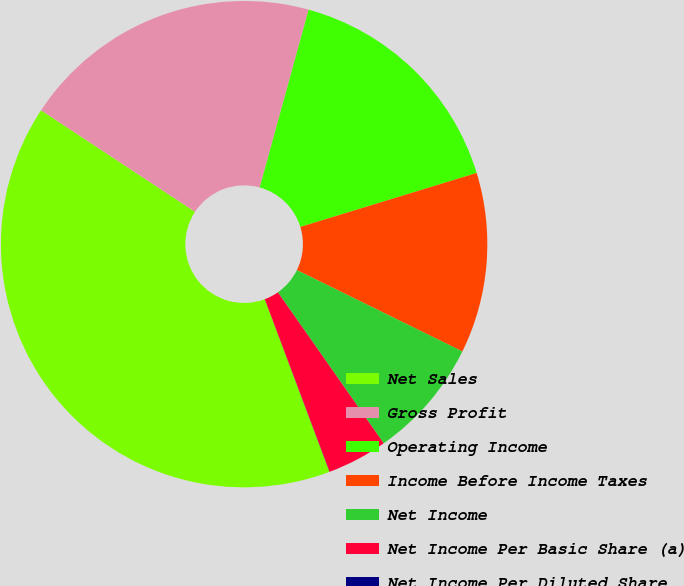Convert chart. <chart><loc_0><loc_0><loc_500><loc_500><pie_chart><fcel>Net Sales<fcel>Gross Profit<fcel>Operating Income<fcel>Income Before Income Taxes<fcel>Net Income<fcel>Net Income Per Basic Share (a)<fcel>Net Income Per Diluted Share<nl><fcel>39.99%<fcel>20.0%<fcel>16.0%<fcel>12.0%<fcel>8.0%<fcel>4.01%<fcel>0.01%<nl></chart> 